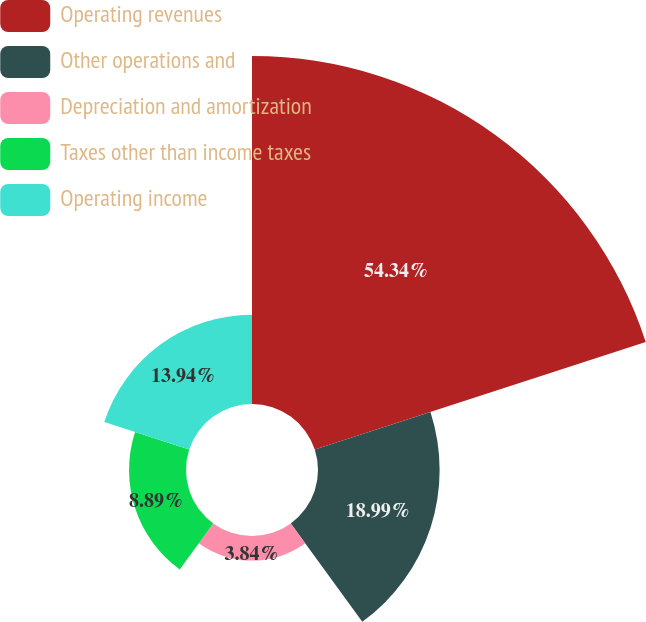Convert chart. <chart><loc_0><loc_0><loc_500><loc_500><pie_chart><fcel>Operating revenues<fcel>Other operations and<fcel>Depreciation and amortization<fcel>Taxes other than income taxes<fcel>Operating income<nl><fcel>54.33%<fcel>18.99%<fcel>3.84%<fcel>8.89%<fcel>13.94%<nl></chart> 